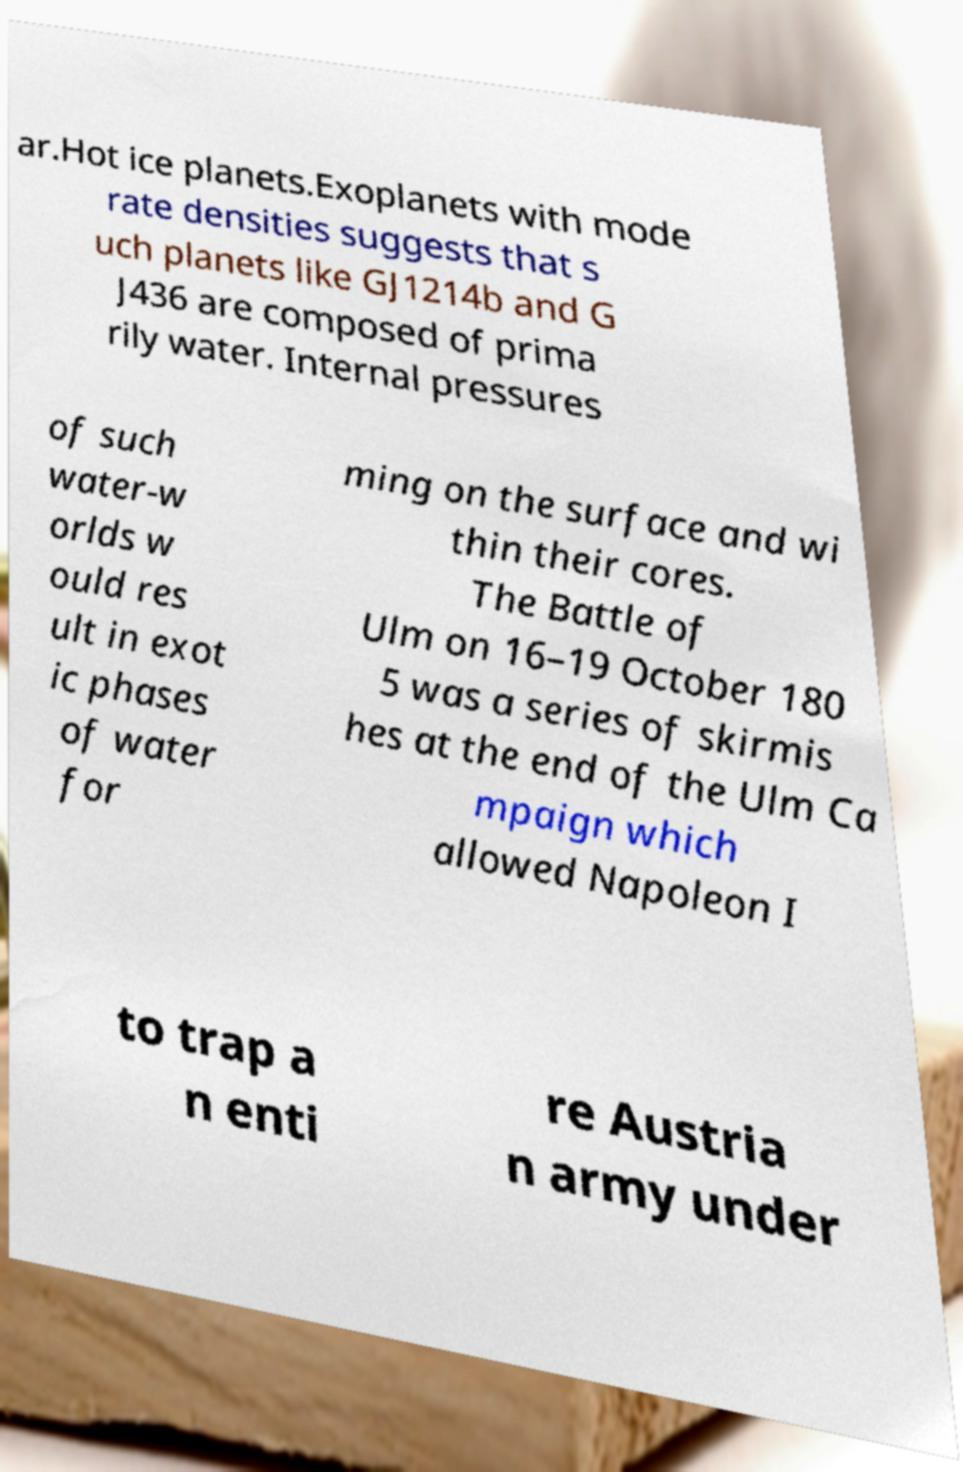Can you accurately transcribe the text from the provided image for me? ar.Hot ice planets.Exoplanets with mode rate densities suggests that s uch planets like GJ1214b and G J436 are composed of prima rily water. Internal pressures of such water-w orlds w ould res ult in exot ic phases of water for ming on the surface and wi thin their cores. The Battle of Ulm on 16–19 October 180 5 was a series of skirmis hes at the end of the Ulm Ca mpaign which allowed Napoleon I to trap a n enti re Austria n army under 